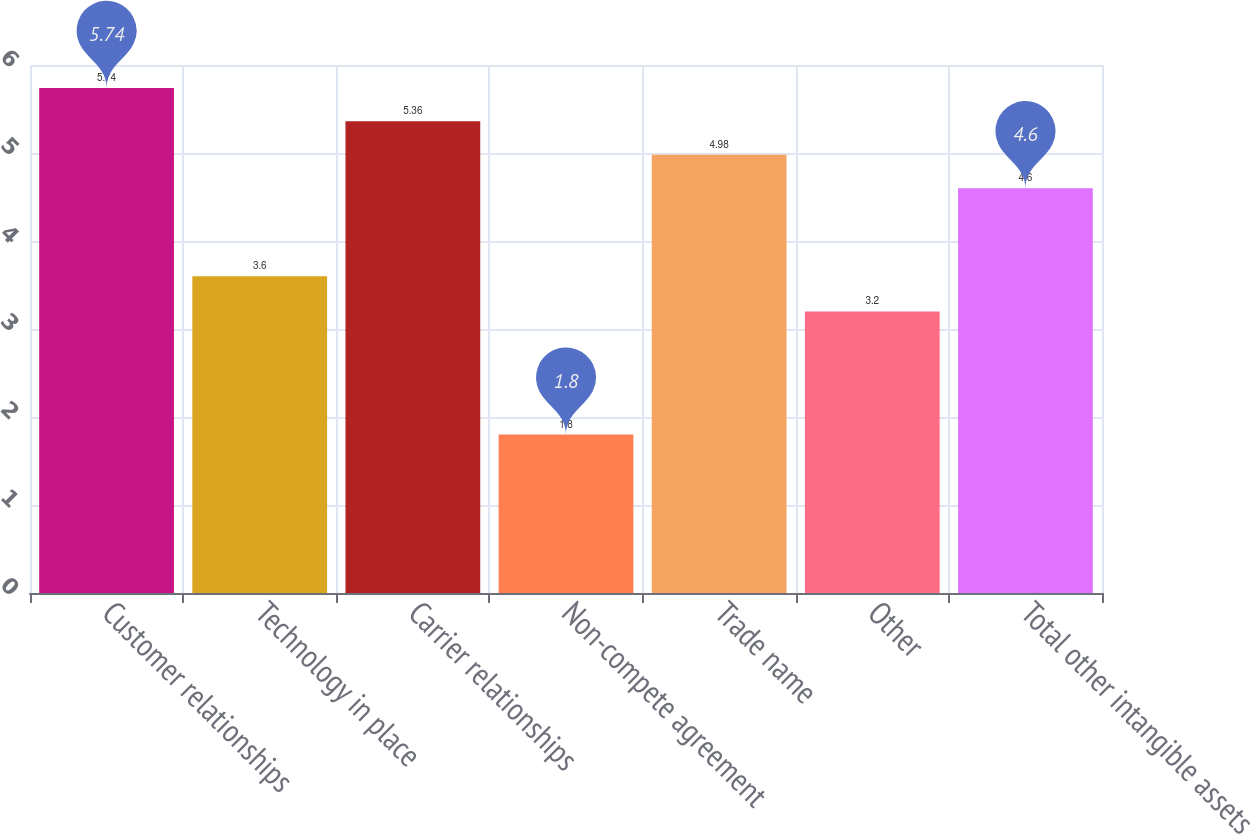Convert chart. <chart><loc_0><loc_0><loc_500><loc_500><bar_chart><fcel>Customer relationships<fcel>Technology in place<fcel>Carrier relationships<fcel>Non-compete agreement<fcel>Trade name<fcel>Other<fcel>Total other intangible assets<nl><fcel>5.74<fcel>3.6<fcel>5.36<fcel>1.8<fcel>4.98<fcel>3.2<fcel>4.6<nl></chart> 